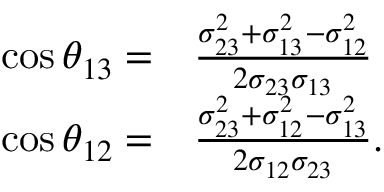<formula> <loc_0><loc_0><loc_500><loc_500>\begin{array} { r l } { \cos \theta _ { 1 3 } = } & { \frac { \sigma _ { 2 3 } ^ { 2 } + \sigma _ { 1 3 } ^ { 2 } - \sigma _ { 1 2 } ^ { 2 } } { 2 \sigma _ { 2 3 } \sigma _ { 1 3 } } } \\ { \cos \theta _ { 1 2 } = } & { \frac { \sigma _ { 2 3 } ^ { 2 } + \sigma _ { 1 2 } ^ { 2 } - \sigma _ { 1 3 } ^ { 2 } } { 2 \sigma _ { 1 2 } \sigma _ { 2 3 } } . } \end{array}</formula> 